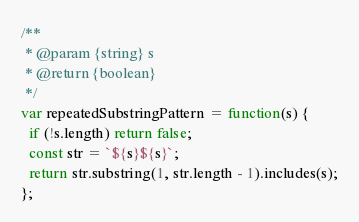<code> <loc_0><loc_0><loc_500><loc_500><_JavaScript_>/**
 * @param {string} s
 * @return {boolean}
 */
var repeatedSubstringPattern = function(s) {
  if (!s.length) return false;
  const str = `${s}${s}`;
  return str.substring(1, str.length - 1).includes(s);
};
</code> 